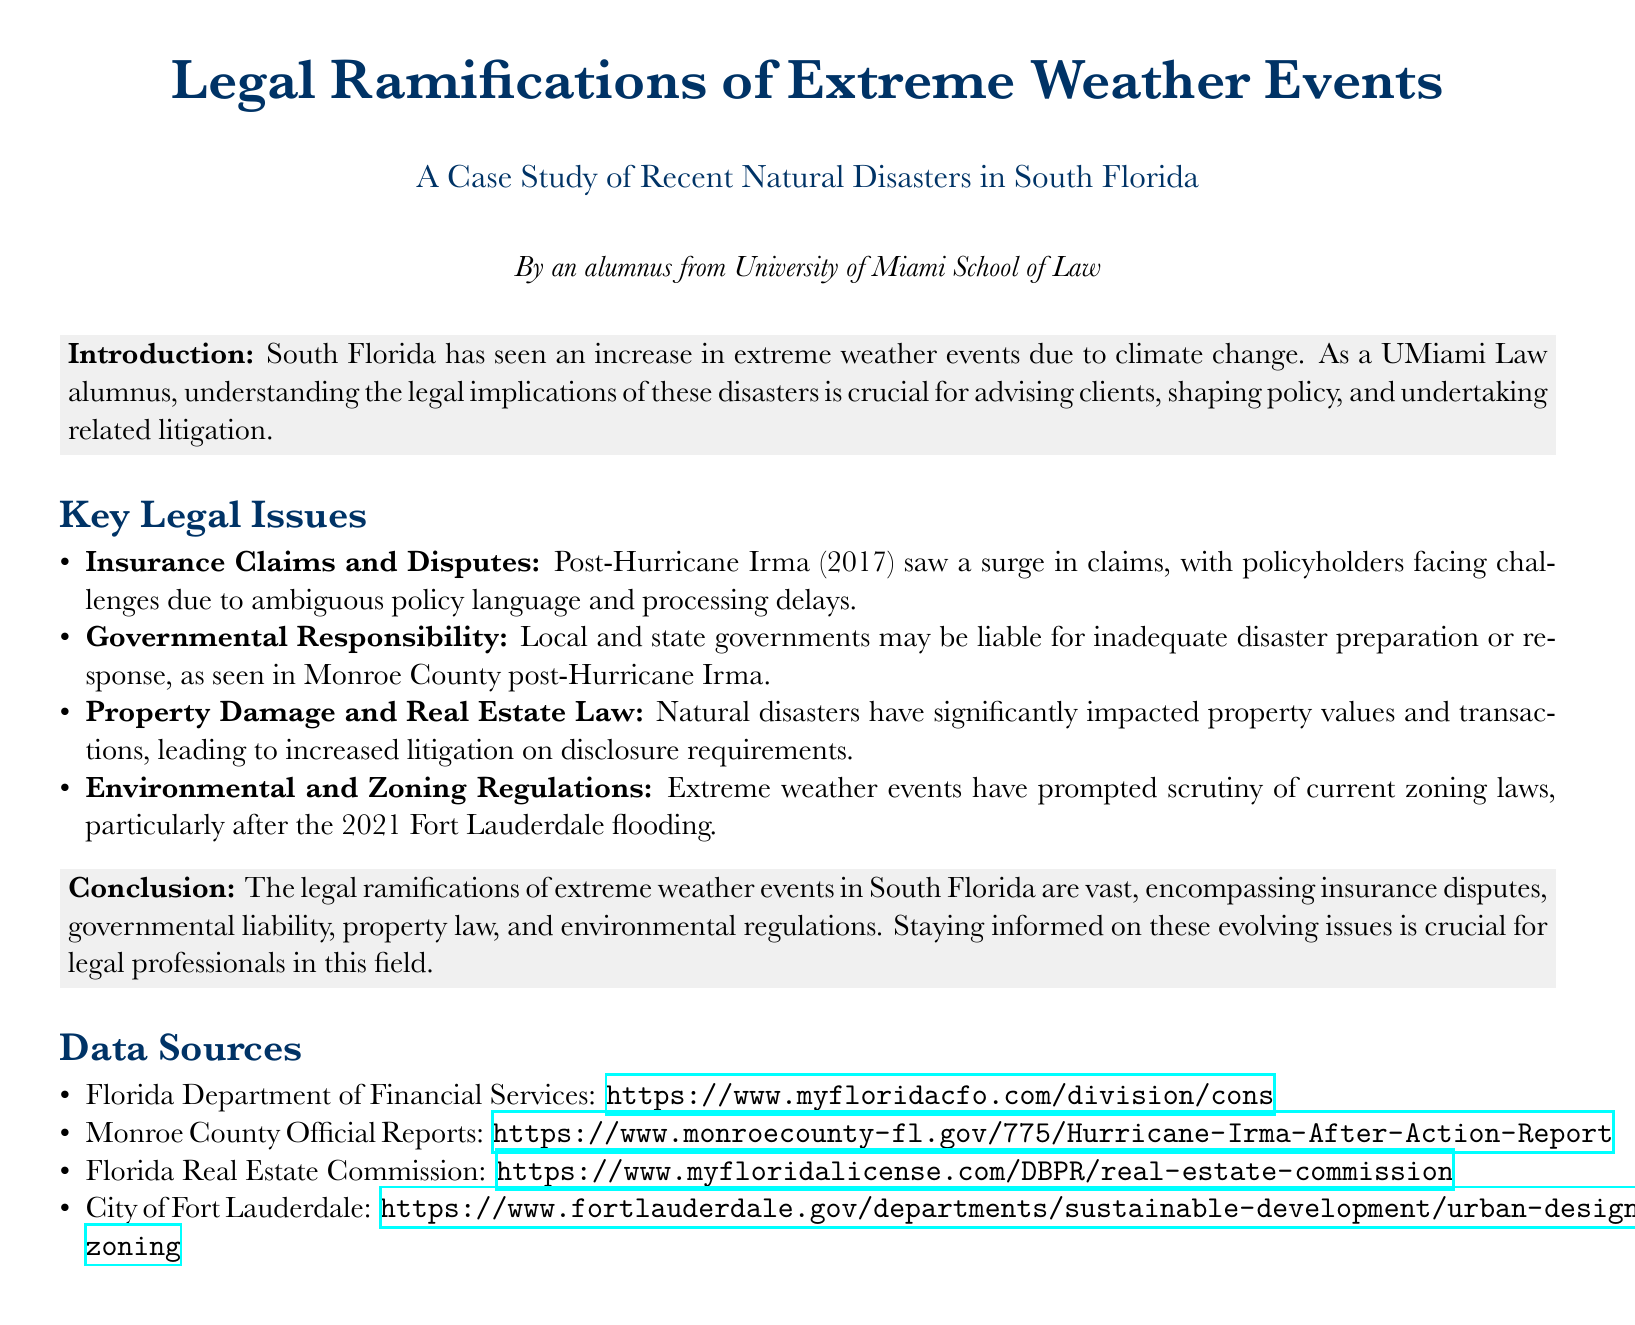What is the title of the document? The title of the document is stated at the top and reads "Legal Ramifications of Extreme Weather Events."
Answer: Legal Ramifications of Extreme Weather Events Who authored the document? The document indicates its author as "an alumnus from University of Miami School of Law."
Answer: an alumnus from University of Miami School of Law What year did Hurricane Irma occur? The document mentions that Hurricane Irma took place in 2017.
Answer: 2017 Which county's reports were cited after Hurricane Irma? The document specifically references Monroe County's official reports.
Answer: Monroe County What specific legal issue involves "ambiguous policy language"? This phrase is associated with "Insurance Claims and Disputes" as described in the document.
Answer: Insurance Claims and Disputes What was scrutinized after the 2021 Fort Lauderdale event? The document states that "zoning laws" were scrutinized after the flooding.
Answer: zoning laws What did the document indicate as a source for real estate information? It lists the "Florida Real Estate Commission" as a source for real estate information.
Answer: Florida Real Estate Commission Which natural disaster prompted increased litigation on disclosure requirements? The document indicates that natural disasters have led to this issue, without specifying a single disaster.
Answer: Natural disasters What color is used for the title text? The document specifies that the title text is "myblue."
Answer: myblue 